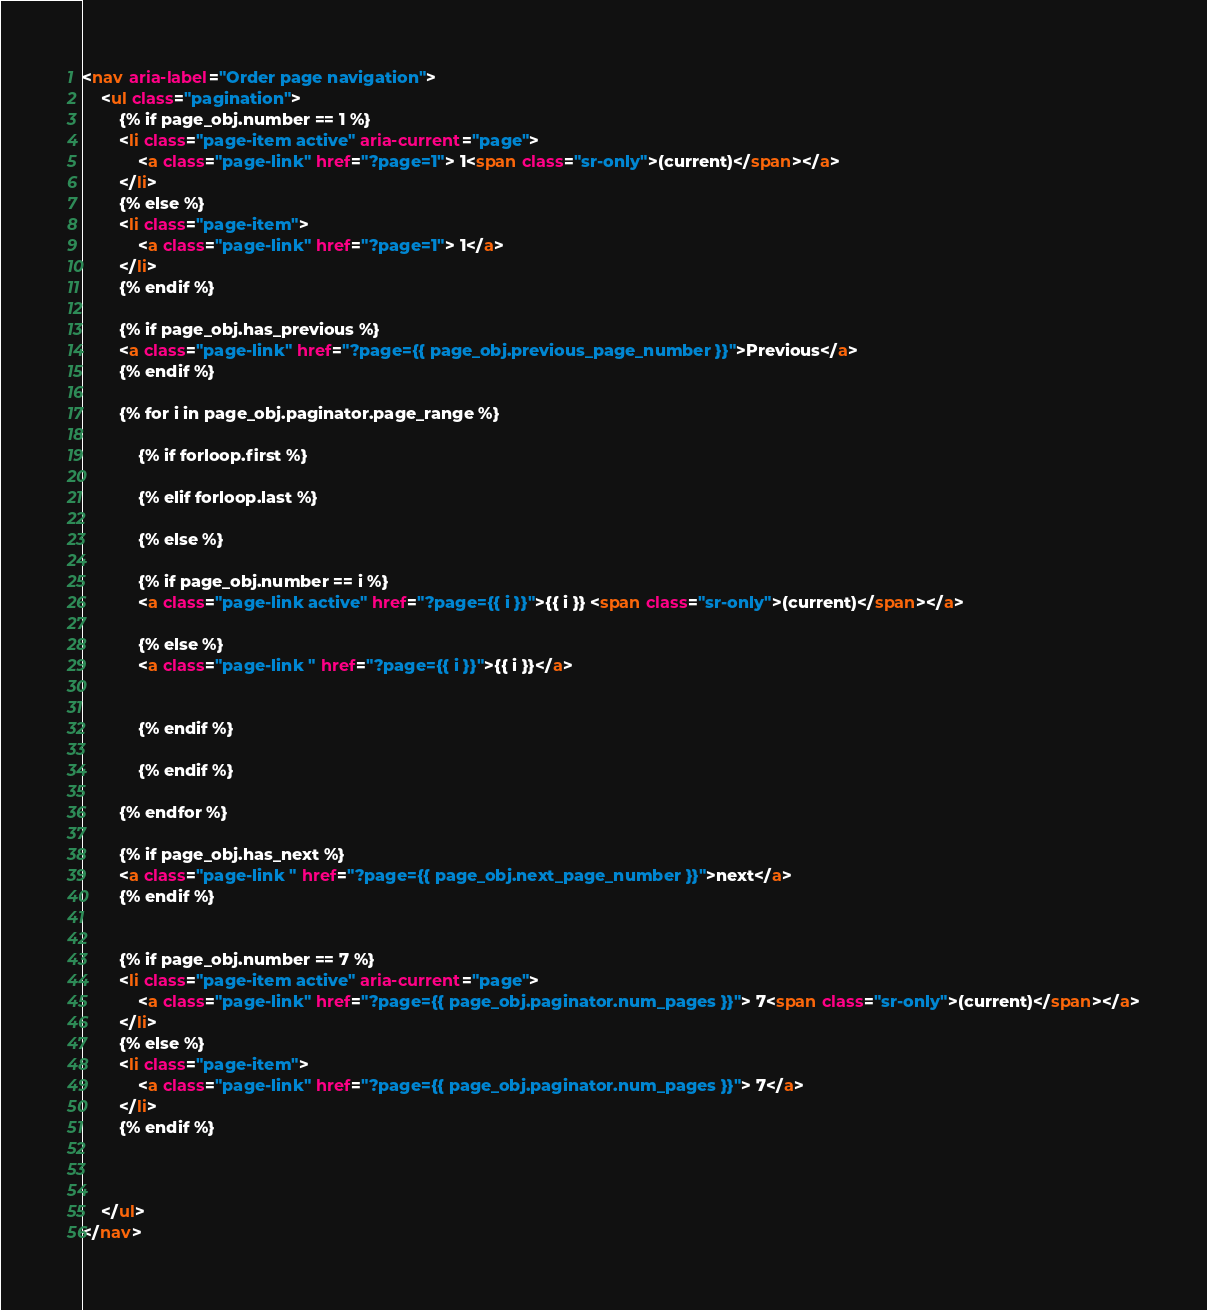<code> <loc_0><loc_0><loc_500><loc_500><_HTML_><nav aria-label="Order page navigation">
    <ul class="pagination">
        {% if page_obj.number == 1 %}
        <li class="page-item active" aria-current="page">
            <a class="page-link" href="?page=1"> 1<span class="sr-only">(current)</span></a>
        </li>
        {% else %}
        <li class="page-item">
            <a class="page-link" href="?page=1"> 1</a>
        </li>
        {% endif %}

        {% if page_obj.has_previous %}
        <a class="page-link" href="?page={{ page_obj.previous_page_number }}">Previous</a>
        {% endif %}
            
        {% for i in page_obj.paginator.page_range %}

            {% if forloop.first %}

            {% elif forloop.last %}

            {% else %}

            {% if page_obj.number == i %}
            <a class="page-link active" href="?page={{ i }}">{{ i }} <span class="sr-only">(current)</span></a>

            {% else %}
            <a class="page-link " href="?page={{ i }}">{{ i }}</a>


            {% endif %} 

            {% endif %} 
        
        {% endfor %} 
                
        {% if page_obj.has_next %}
        <a class="page-link " href="?page={{ page_obj.next_page_number }}">next</a>
        {% endif %}


        {% if page_obj.number == 7 %}
        <li class="page-item active" aria-current="page">
            <a class="page-link" href="?page={{ page_obj.paginator.num_pages }}"> 7<span class="sr-only">(current)</span></a>
        </li>
        {% else %}
        <li class="page-item">
            <a class="page-link" href="?page={{ page_obj.paginator.num_pages }}"> 7</a>
        </li>
        {% endif %}

            

    </ul>
</nav></code> 